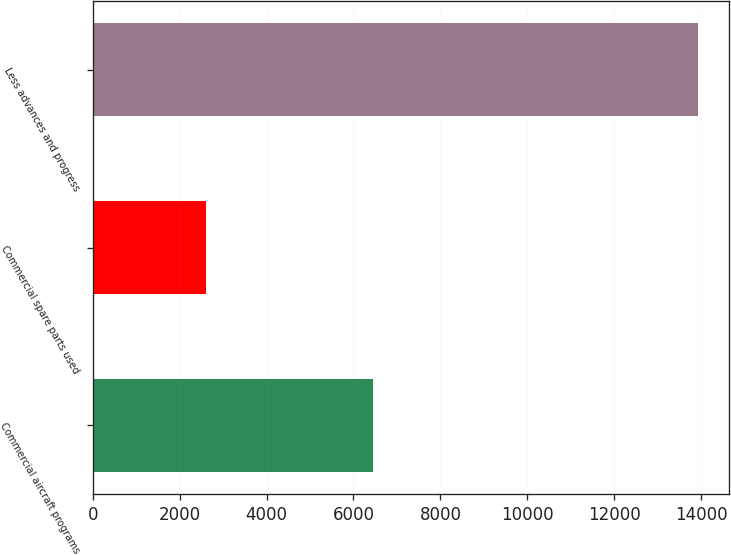Convert chart. <chart><loc_0><loc_0><loc_500><loc_500><bar_chart><fcel>Commercial aircraft programs<fcel>Commercial spare parts used<fcel>Less advances and progress<nl><fcel>6448<fcel>2596<fcel>13934<nl></chart> 